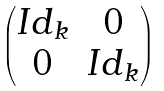<formula> <loc_0><loc_0><loc_500><loc_500>\begin{pmatrix} I d _ { k } & 0 \\ 0 & I d _ { k } \end{pmatrix}</formula> 